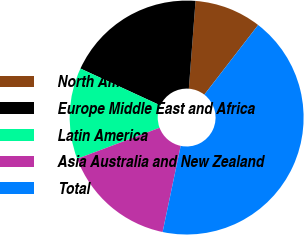Convert chart to OTSL. <chart><loc_0><loc_0><loc_500><loc_500><pie_chart><fcel>North America<fcel>Europe Middle East and Africa<fcel>Latin America<fcel>Asia Australia and New Zealand<fcel>Total<nl><fcel>9.26%<fcel>19.33%<fcel>12.62%<fcel>15.97%<fcel>42.82%<nl></chart> 